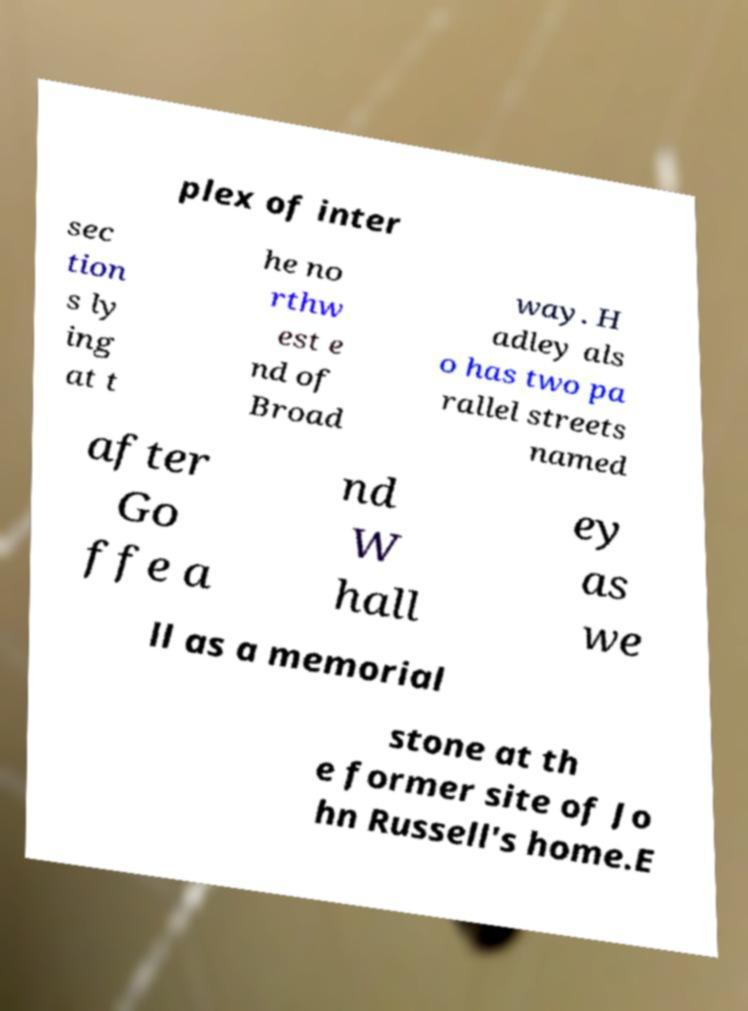What messages or text are displayed in this image? I need them in a readable, typed format. plex of inter sec tion s ly ing at t he no rthw est e nd of Broad way. H adley als o has two pa rallel streets named after Go ffe a nd W hall ey as we ll as a memorial stone at th e former site of Jo hn Russell's home.E 